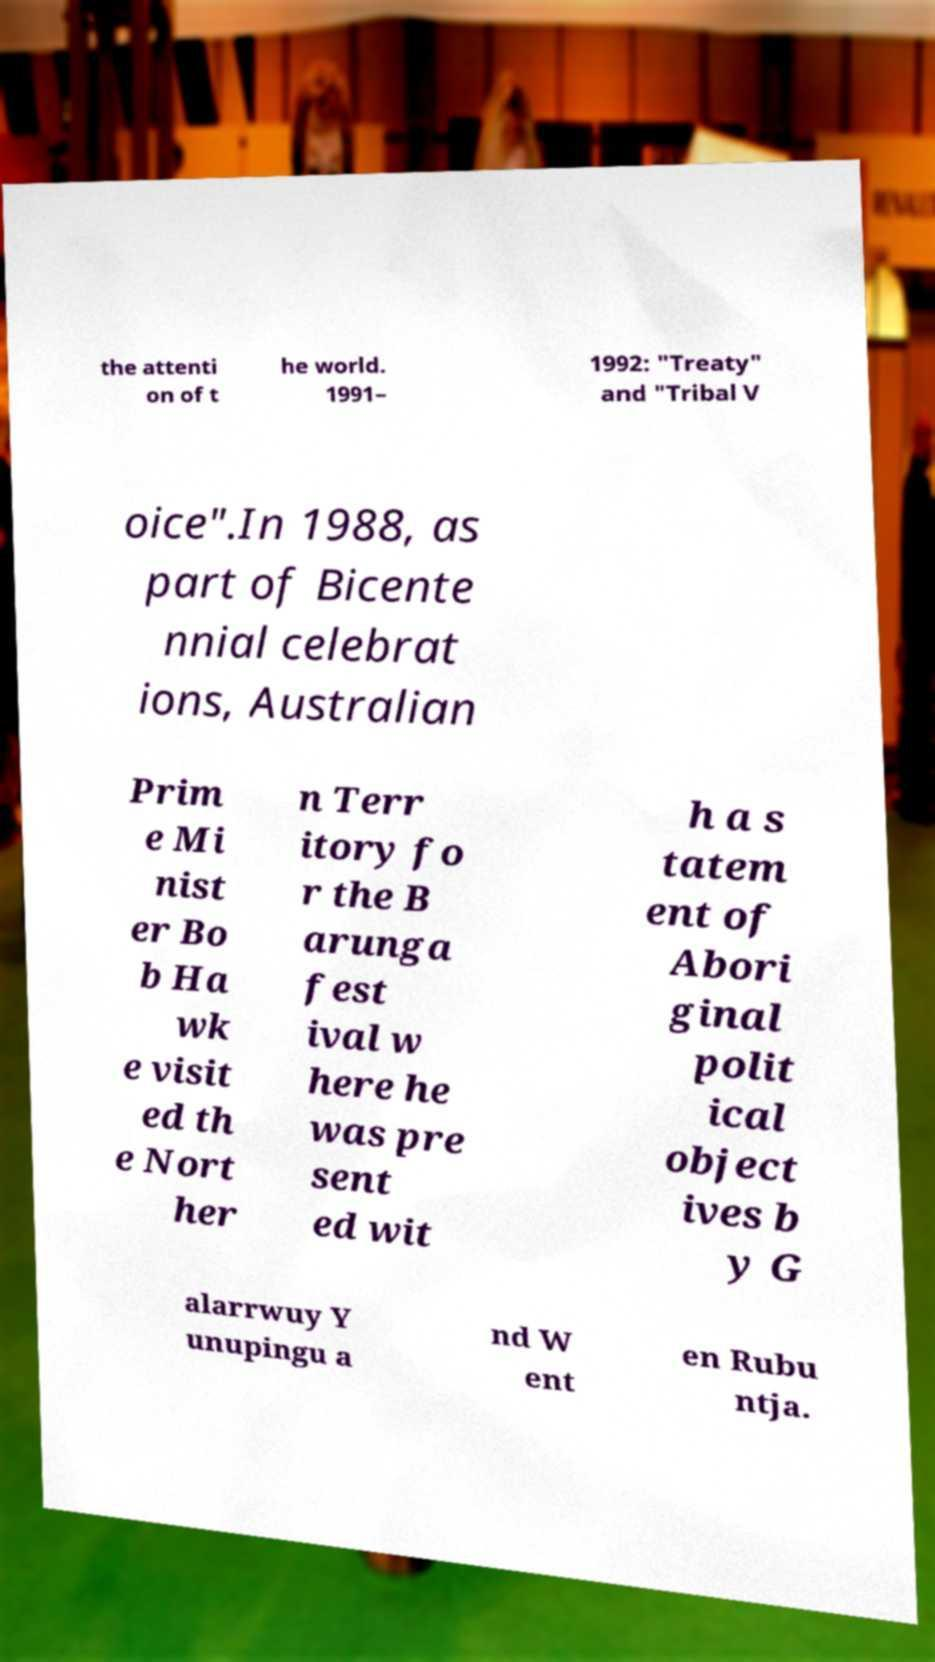Please read and relay the text visible in this image. What does it say? the attenti on of t he world. 1991– 1992: "Treaty" and "Tribal V oice".In 1988, as part of Bicente nnial celebrat ions, Australian Prim e Mi nist er Bo b Ha wk e visit ed th e Nort her n Terr itory fo r the B arunga fest ival w here he was pre sent ed wit h a s tatem ent of Abori ginal polit ical object ives b y G alarrwuy Y unupingu a nd W ent en Rubu ntja. 